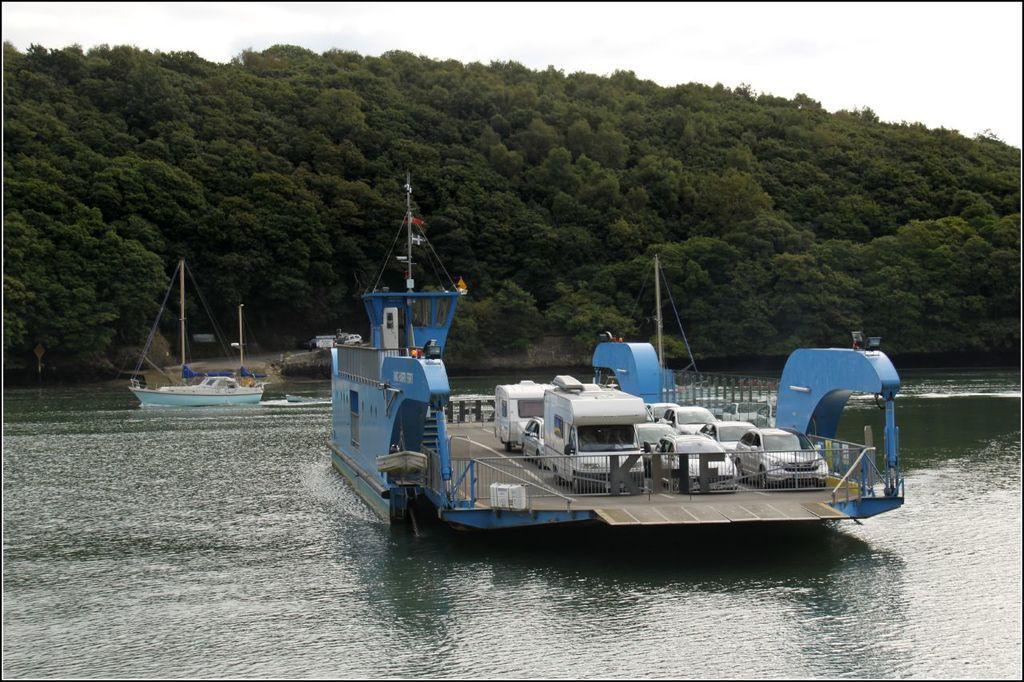In one or two sentences, can you explain what this image depicts? In this image I can see two boats on the water. In the front of the image I can see number of vehicles on the boat. In the background I can see number of trees and on the top side of the image I can see the sky. 